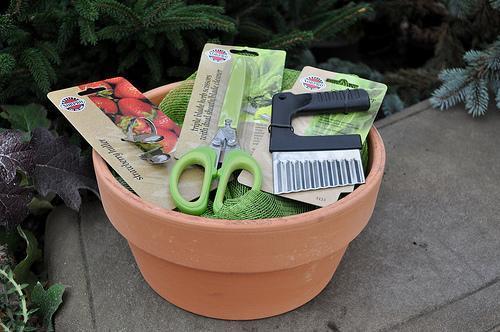How many bowls are there?
Give a very brief answer. 1. 